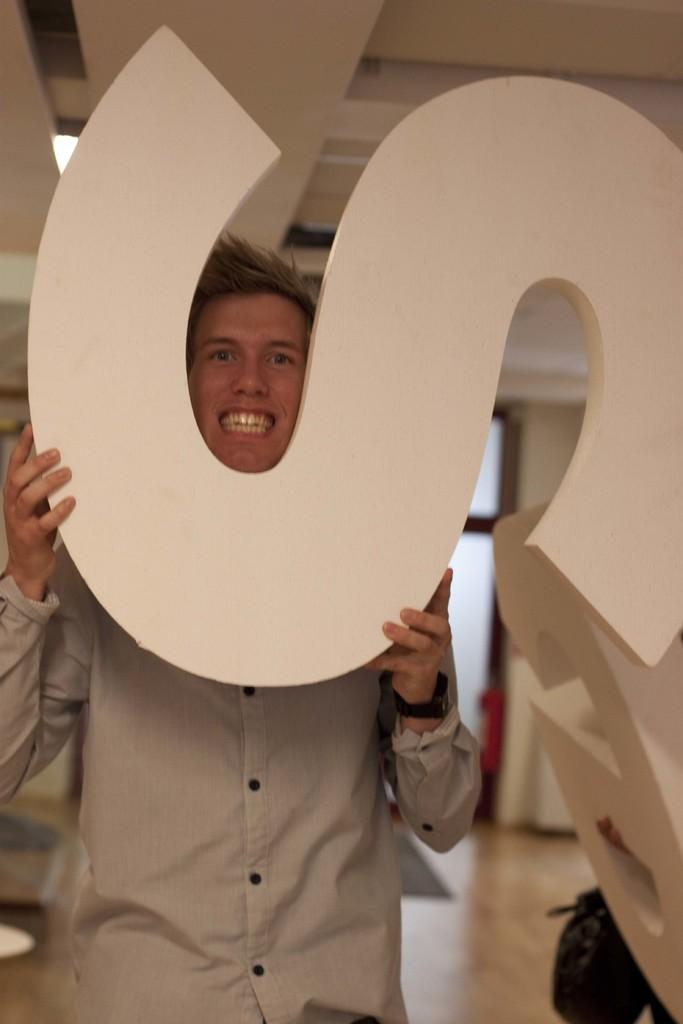What can be seen in the image? There is a person in the image. What is the person holding in their hand? The person is holding a letter S in their hand. Can you describe the background of the image? There is a red object in the background of the image. What type of plantation can be seen in the background of the image? There is no plantation present in the image; it only features a person holding a letter S and a red object in the background. 